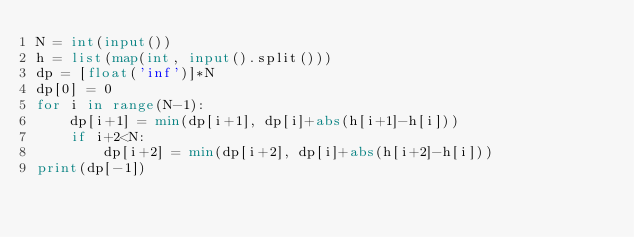<code> <loc_0><loc_0><loc_500><loc_500><_Python_>N = int(input())
h = list(map(int, input().split()))
dp = [float('inf')]*N
dp[0] = 0
for i in range(N-1):
    dp[i+1] = min(dp[i+1], dp[i]+abs(h[i+1]-h[i]))
    if i+2<N:
        dp[i+2] = min(dp[i+2], dp[i]+abs(h[i+2]-h[i]))
print(dp[-1])
</code> 